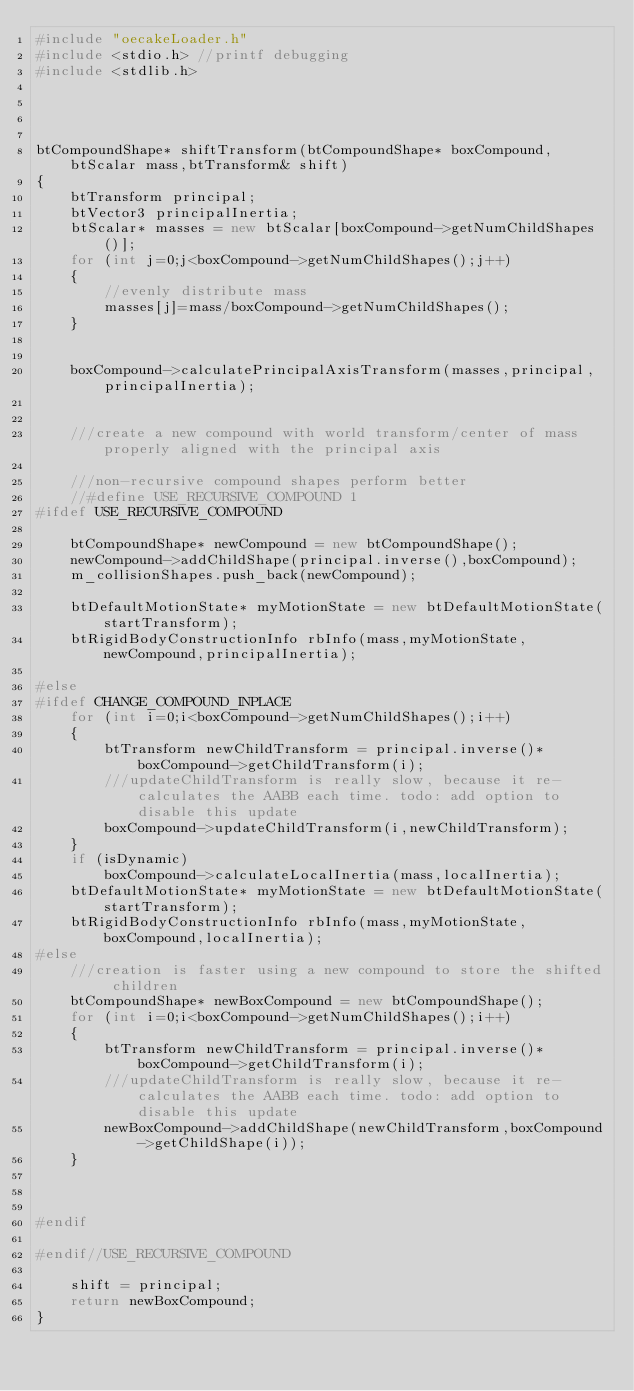<code> <loc_0><loc_0><loc_500><loc_500><_C++_>#include "oecakeLoader.h"
#include <stdio.h> //printf debugging
#include <stdlib.h>




btCompoundShape* shiftTransform(btCompoundShape* boxCompound,btScalar mass,btTransform& shift)
{
	btTransform principal;
	btVector3 principalInertia;
	btScalar* masses = new btScalar[boxCompound->getNumChildShapes()];
	for (int j=0;j<boxCompound->getNumChildShapes();j++)
	{
		//evenly distribute mass
		masses[j]=mass/boxCompound->getNumChildShapes();
	}


	boxCompound->calculatePrincipalAxisTransform(masses,principal,principalInertia);


	///create a new compound with world transform/center of mass properly aligned with the principal axis

	///non-recursive compound shapes perform better
	//#define USE_RECURSIVE_COMPOUND 1
#ifdef USE_RECURSIVE_COMPOUND

	btCompoundShape* newCompound = new btCompoundShape();
	newCompound->addChildShape(principal.inverse(),boxCompound);
	m_collisionShapes.push_back(newCompound);

	btDefaultMotionState* myMotionState = new btDefaultMotionState(startTransform);
	btRigidBodyConstructionInfo rbInfo(mass,myMotionState,newCompound,principalInertia);

#else
#ifdef CHANGE_COMPOUND_INPLACE
	for (int i=0;i<boxCompound->getNumChildShapes();i++)
	{
		btTransform newChildTransform = principal.inverse()*boxCompound->getChildTransform(i);
		///updateChildTransform is really slow, because it re-calculates the AABB each time. todo: add option to disable this update
		boxCompound->updateChildTransform(i,newChildTransform);
	}
	if (isDynamic)
		boxCompound->calculateLocalInertia(mass,localInertia);
	btDefaultMotionState* myMotionState = new btDefaultMotionState(startTransform);
	btRigidBodyConstructionInfo rbInfo(mass,myMotionState,boxCompound,localInertia);
#else
	///creation is faster using a new compound to store the shifted children
	btCompoundShape* newBoxCompound = new btCompoundShape();
	for (int i=0;i<boxCompound->getNumChildShapes();i++)
	{
		btTransform newChildTransform = principal.inverse()*boxCompound->getChildTransform(i);
		///updateChildTransform is really slow, because it re-calculates the AABB each time. todo: add option to disable this update
		newBoxCompound->addChildShape(newChildTransform,boxCompound->getChildShape(i));
	}



#endif

#endif//USE_RECURSIVE_COMPOUND

	shift = principal;
	return newBoxCompound;
}

</code> 